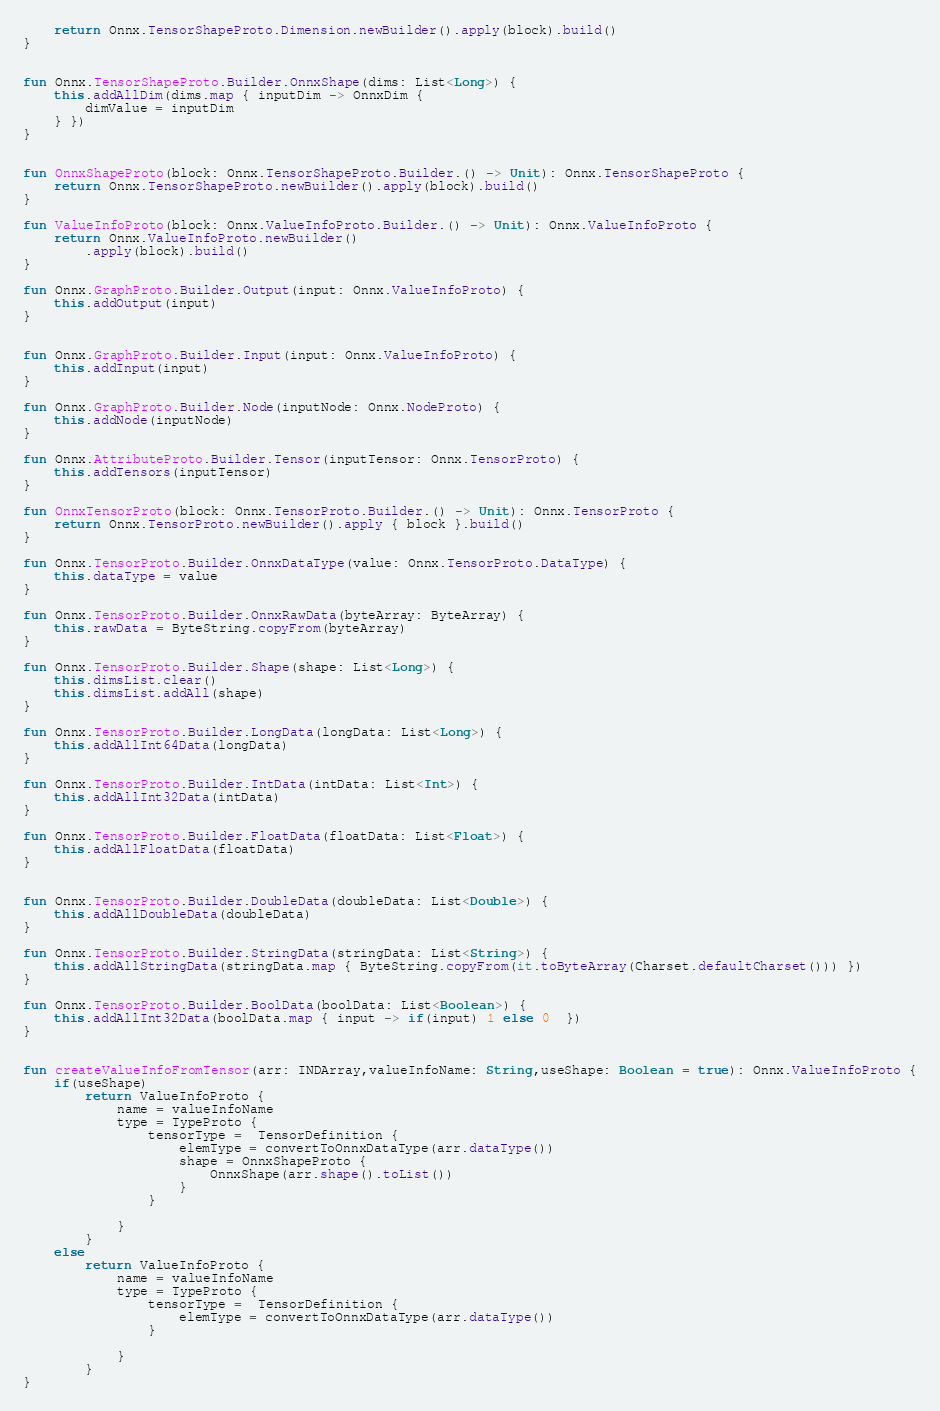<code> <loc_0><loc_0><loc_500><loc_500><_Kotlin_>    return Onnx.TensorShapeProto.Dimension.newBuilder().apply(block).build()
}


fun Onnx.TensorShapeProto.Builder.OnnxShape(dims: List<Long>) {
    this.addAllDim(dims.map { inputDim -> OnnxDim {
        dimValue = inputDim
    } })
}


fun OnnxShapeProto(block: Onnx.TensorShapeProto.Builder.() -> Unit): Onnx.TensorShapeProto {
    return Onnx.TensorShapeProto.newBuilder().apply(block).build()
}

fun ValueInfoProto(block: Onnx.ValueInfoProto.Builder.() -> Unit): Onnx.ValueInfoProto {
    return Onnx.ValueInfoProto.newBuilder()
        .apply(block).build()
}

fun Onnx.GraphProto.Builder.Output(input: Onnx.ValueInfoProto) {
    this.addOutput(input)
}


fun Onnx.GraphProto.Builder.Input(input: Onnx.ValueInfoProto) {
    this.addInput(input)
}

fun Onnx.GraphProto.Builder.Node(inputNode: Onnx.NodeProto) {
    this.addNode(inputNode)
}

fun Onnx.AttributeProto.Builder.Tensor(inputTensor: Onnx.TensorProto) {
    this.addTensors(inputTensor)
}

fun OnnxTensorProto(block: Onnx.TensorProto.Builder.() -> Unit): Onnx.TensorProto {
    return Onnx.TensorProto.newBuilder().apply { block }.build()
}

fun Onnx.TensorProto.Builder.OnnxDataType(value: Onnx.TensorProto.DataType) {
    this.dataType = value
}

fun Onnx.TensorProto.Builder.OnnxRawData(byteArray: ByteArray) {
    this.rawData = ByteString.copyFrom(byteArray)
}

fun Onnx.TensorProto.Builder.Shape(shape: List<Long>) {
    this.dimsList.clear()
    this.dimsList.addAll(shape)
}

fun Onnx.TensorProto.Builder.LongData(longData: List<Long>) {
    this.addAllInt64Data(longData)
}

fun Onnx.TensorProto.Builder.IntData(intData: List<Int>) {
    this.addAllInt32Data(intData)
}

fun Onnx.TensorProto.Builder.FloatData(floatData: List<Float>) {
    this.addAllFloatData(floatData)
}


fun Onnx.TensorProto.Builder.DoubleData(doubleData: List<Double>) {
    this.addAllDoubleData(doubleData)
}

fun Onnx.TensorProto.Builder.StringData(stringData: List<String>) {
    this.addAllStringData(stringData.map { ByteString.copyFrom(it.toByteArray(Charset.defaultCharset())) })
}

fun Onnx.TensorProto.Builder.BoolData(boolData: List<Boolean>) {
    this.addAllInt32Data(boolData.map { input -> if(input) 1 else 0  })
}


fun createValueInfoFromTensor(arr: INDArray,valueInfoName: String,useShape: Boolean = true): Onnx.ValueInfoProto {
    if(useShape)
        return ValueInfoProto {
            name = valueInfoName
            type = TypeProto {
                tensorType =  TensorDefinition {
                    elemType = convertToOnnxDataType(arr.dataType())
                    shape = OnnxShapeProto {
                        OnnxShape(arr.shape().toList())
                    }
                }

            }
        }
    else
        return ValueInfoProto {
            name = valueInfoName
            type = TypeProto {
                tensorType =  TensorDefinition {
                    elemType = convertToOnnxDataType(arr.dataType())
                }

            }
        }
}</code> 